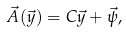Convert formula to latex. <formula><loc_0><loc_0><loc_500><loc_500>\vec { A } ( \vec { y } ) = C \vec { y } + \vec { \psi } ,</formula> 